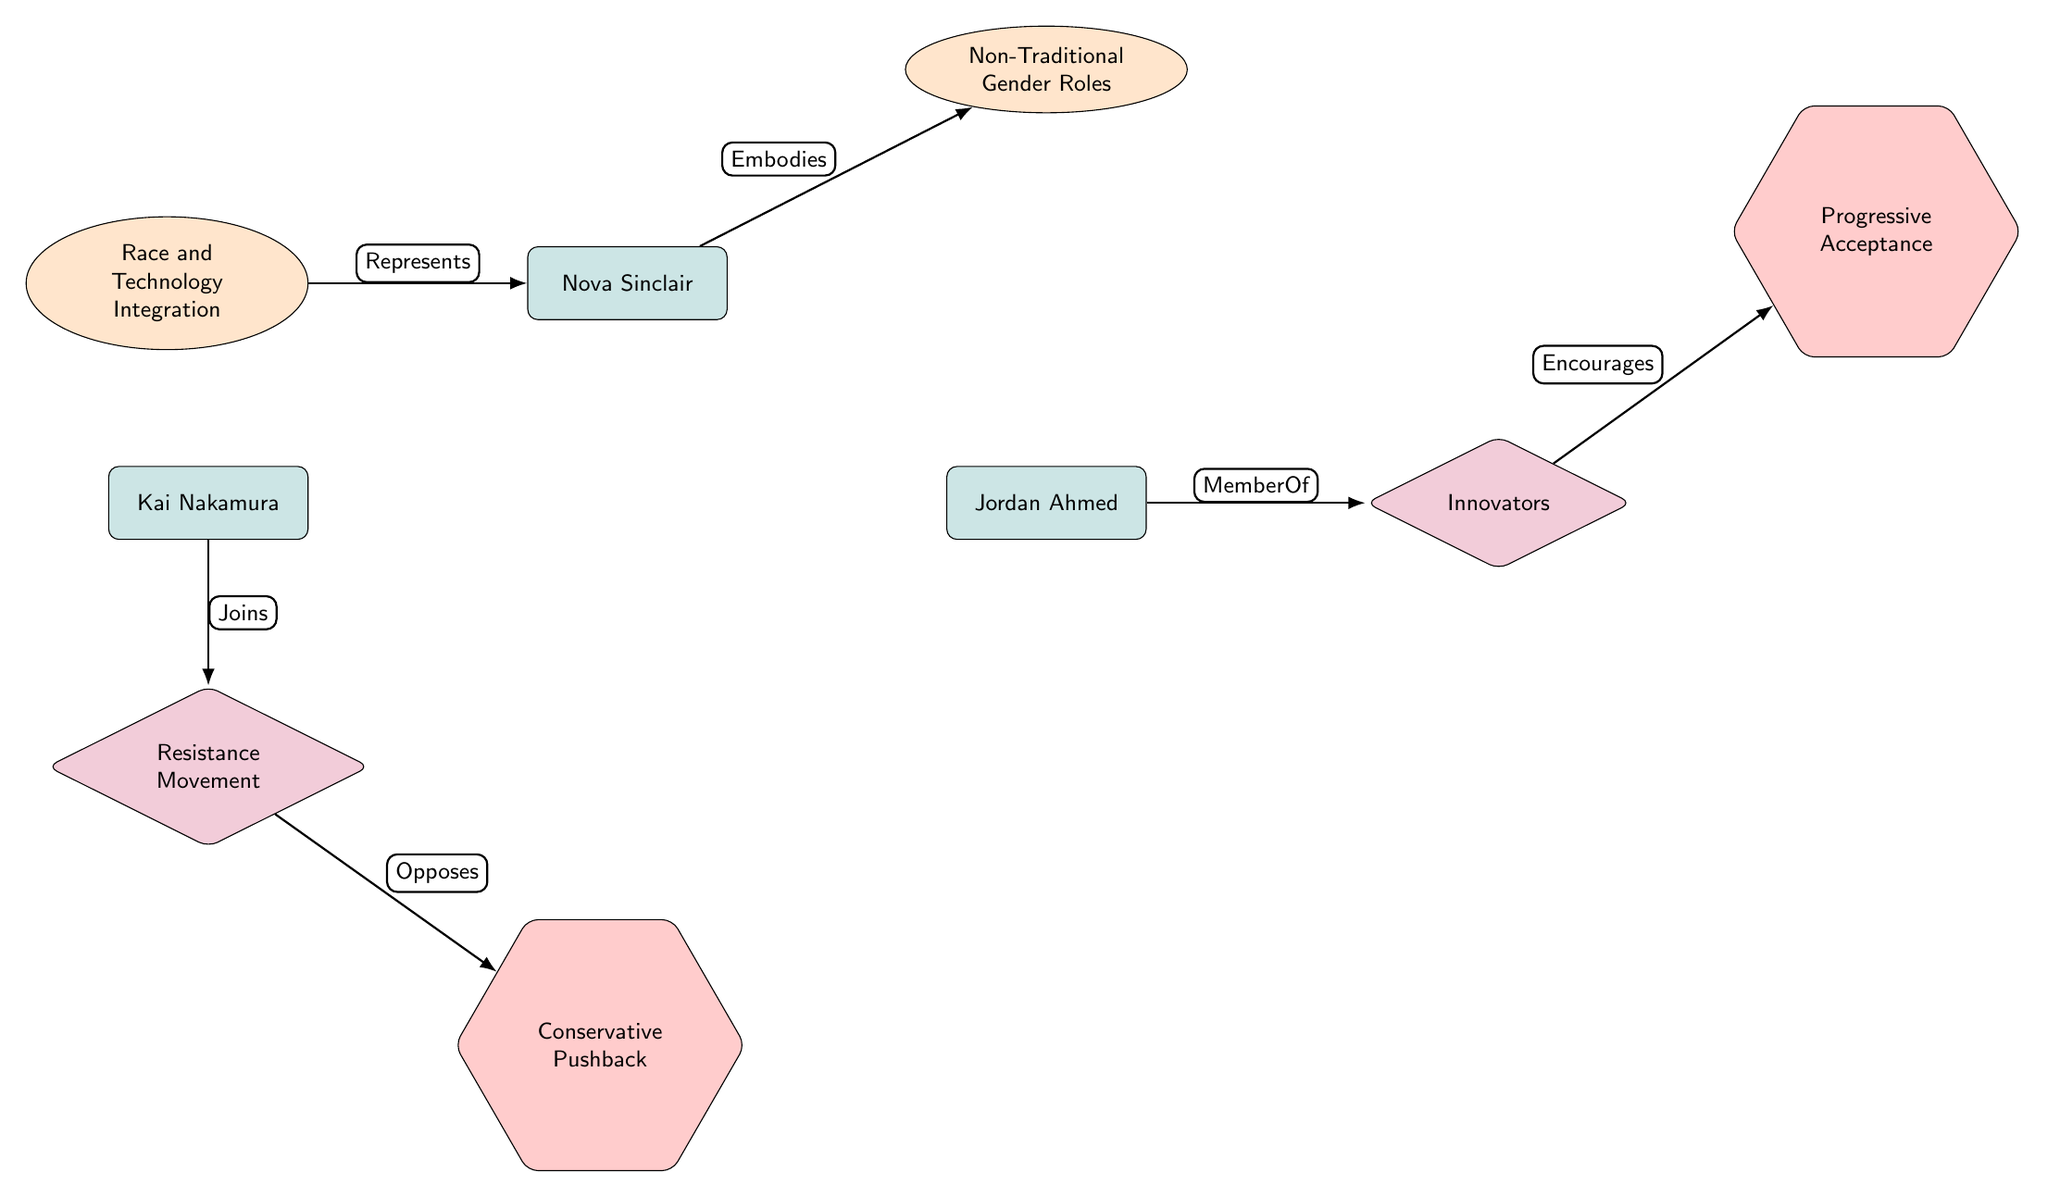What character embodies Non-Traditional Gender Roles? The diagram shows an edge labeled "Embodies" connecting Nova Sinclair to the stereotype of Non-Traditional Gender Roles. This indicates that Nova Sinclair embodies this specific stereotype.
Answer: Nova Sinclair How many stereotypes are represented in the diagram? By counting the nodes under the stereotype category in the diagram, there are two stereotypes: Non-Traditional Gender Roles and Race and Technology Integration. Hence, the total number is two.
Answer: 2 What role does Jordan Ahmed belong to? The diagram depicts an edge labeled "MemberOf" connecting Jordan Ahmed to the role of Innovators. This means that Jordan Ahmed is associated with or belongs to the Innovators.
Answer: Innovators Which societal reaction does the Resistance Movement oppose? The diagram illustrates an edge labeled "Opposes" that connects the Resistance Movement to Conservative Pushback. This indicates that the Resistance Movement directly opposes Conservative Pushback.
Answer: Conservative Pushback What does the Innovators role encourage? The diagram shows an edge labeled "Encourages" leading from the role of Innovators to the societal reaction of Progressive Acceptance. Therefore, the Innovators role encourages Progressive Acceptance.
Answer: Progressive Acceptance How many edges are in the diagram? By counting the connections (edges) between the nodes, there are a total of six edges present in the diagram. This represents the relationships between the characters, stereotypes, roles, and societal reactions.
Answer: 6 What does Nova Sinclair represent in terms of stereotypes? Nova Sinclair is connected to the stereotype of Race and Technology Integration by an edge labeled "Represents". This indicates that Nova Sinclair is representative of this particular stereotype.
Answer: Race and Technology Integration Who joins the Resistance Movement? The diagram shows an edge labeled "Joins" connecting Kai Nakamura to the Resistance Movement. This means that Kai Nakamura is the character that joins this movement.
Answer: Kai Nakamura 